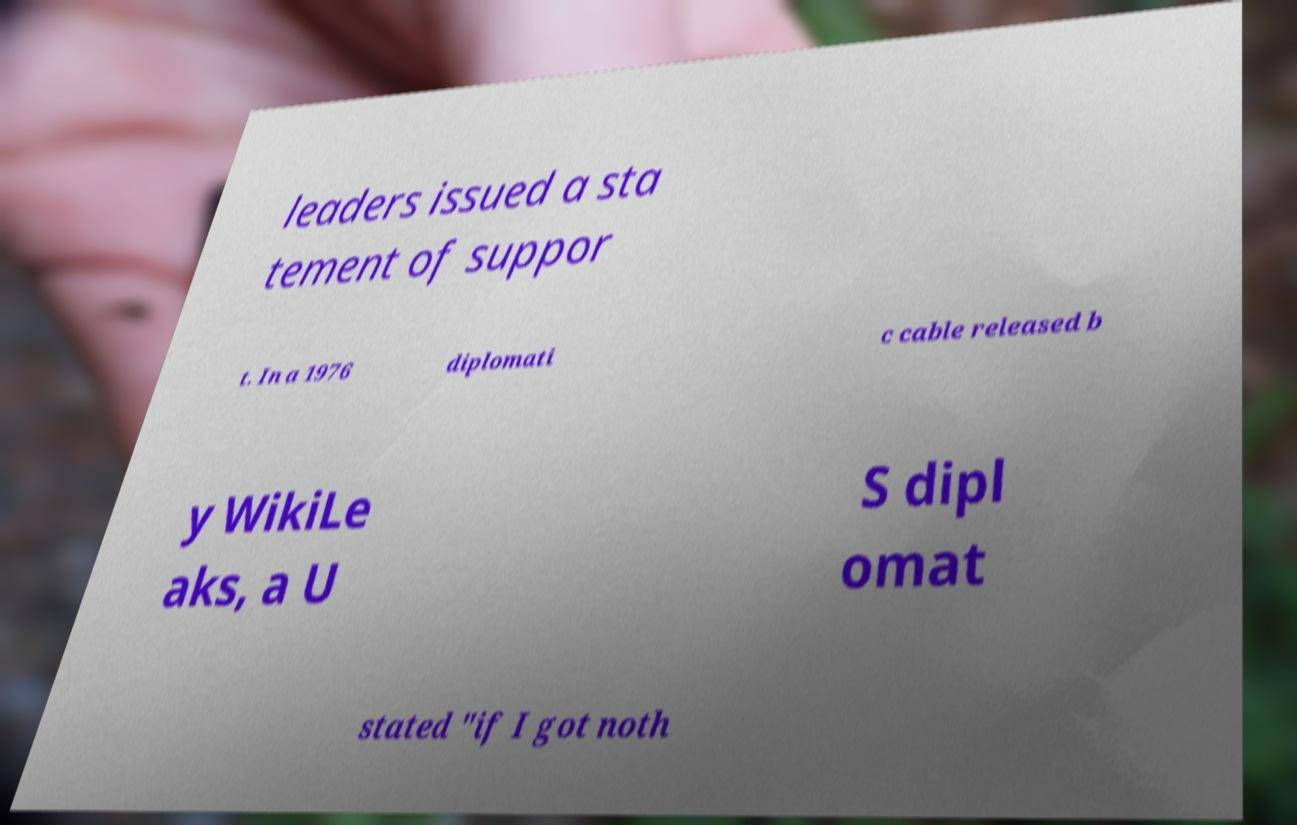What messages or text are displayed in this image? I need them in a readable, typed format. leaders issued a sta tement of suppor t. In a 1976 diplomati c cable released b y WikiLe aks, a U S dipl omat stated "if I got noth 